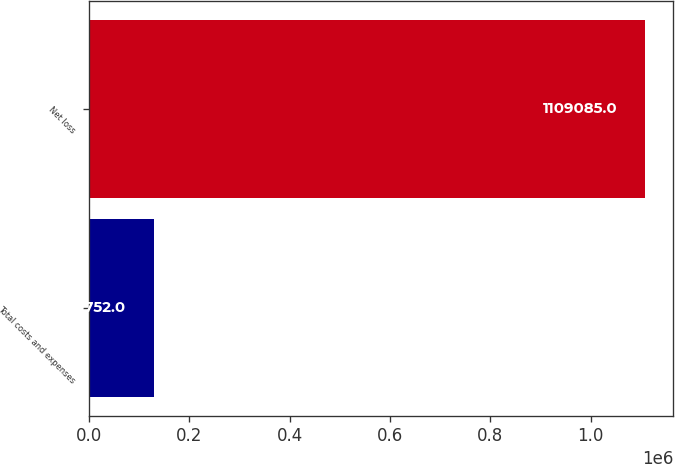Convert chart to OTSL. <chart><loc_0><loc_0><loc_500><loc_500><bar_chart><fcel>Total costs and expenses<fcel>Net loss<nl><fcel>129752<fcel>1.10908e+06<nl></chart> 